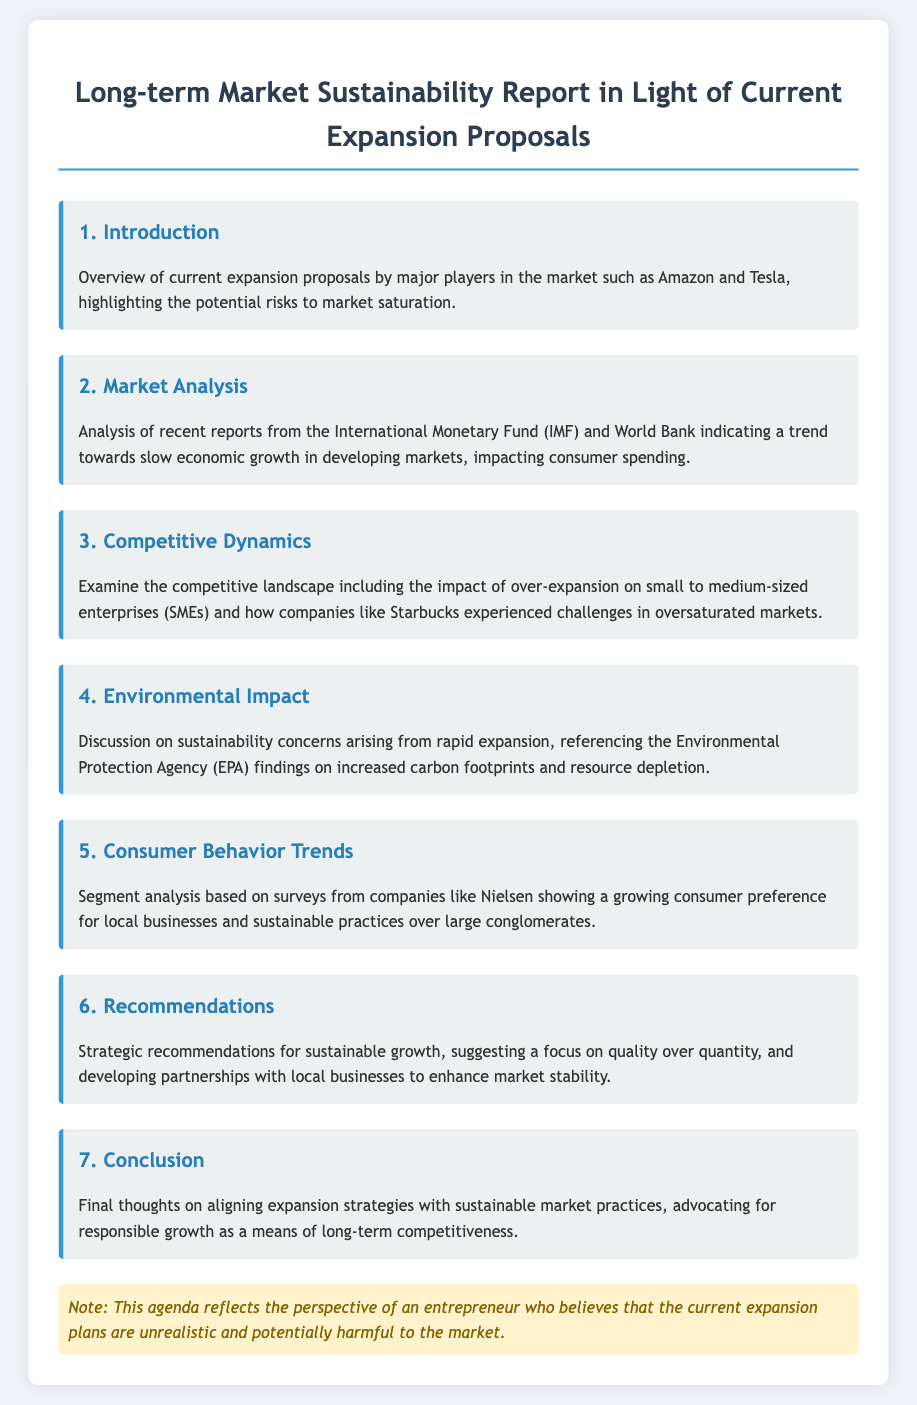What is the title of the report? The title is specified in the main heading of the document.
Answer: Long-term Market Sustainability Report in Light of Current Expansion Proposals Who are the major players mentioned in the introduction? The introduction specifically lists major players involved in the current proposals.
Answer: Amazon and Tesla What does the market analysis indicate about economic growth? The analysis refers to certain reports that discuss economic trends.
Answer: Slow economic growth Which organization’s findings are referenced regarding environmental impact? The section on environmental impact mentions a specific agency's findings.
Answer: Environmental Protection Agency (EPA) What consumer preference trend is highlighted in the consumer behavior trends section? The document discusses a particular preference noted in surveys.
Answer: Preference for local businesses and sustainable practices How many sections are there in the report? The document outlines different sections, which can be counted.
Answer: Seven What specific recommendation is made for sustainable growth? The recommendations section specifies a strategic focus.
Answer: Quality over quantity Which market players experienced challenges due to oversaturation? The competitive dynamics section provides an example of companies affected by oversaturation.
Answer: Starbucks 